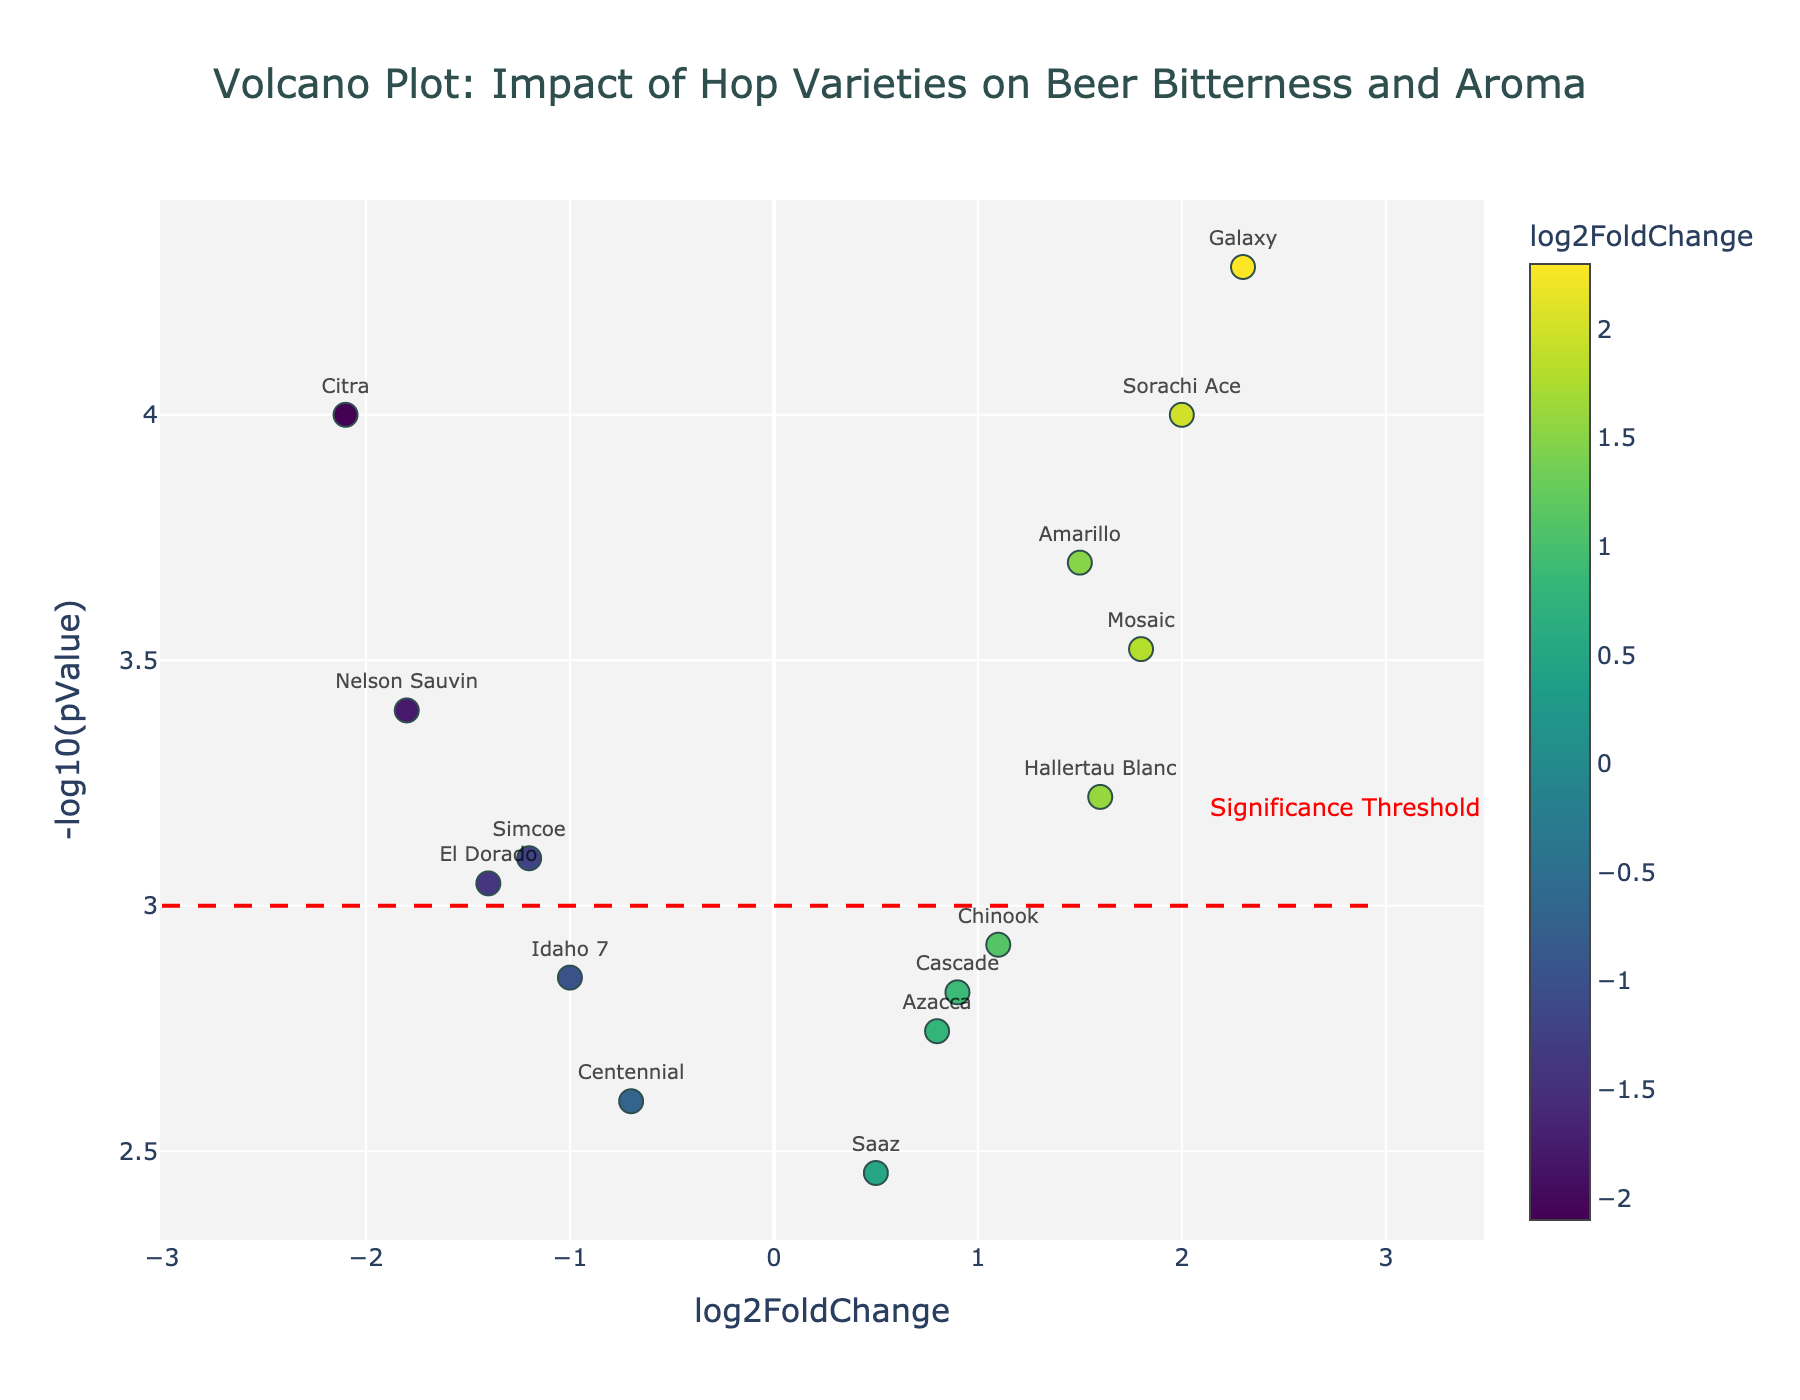Which hop variety has the highest absolute value of log2FoldChange? To find the variety with the highest absolute value of log2FoldChange, observe both positive and negative values. The hop variety with the most extreme value is "Galaxy" with a log2FoldChange of 2.3.
Answer: Galaxy What is the significance threshold for p-values in this plot? The plot shows a red dashed line at y = 3, which corresponds to the -log10(pValue) signifying the significance threshold for p-values.
Answer: -log10(pValue) = 3 How many hop varieties lie above the significance threshold? To determine this, count the data points above the red dashed line at y = 3. There are 8 data points above this threshold.
Answer: 8 Which hop variety has the smallest p-value? The smallest p-value corresponds to the highest -log10(pValue). "Galaxy" has the highest -log10(pValue), thus the smallest p-value.
Answer: Galaxy What is the log2FoldChange for Citra? The log2FoldChange for Citra can be read directly from the plot, where Citra is at a log2FoldChange of -2.1.
Answer: -2.1 Which hop variety has the highest positive log2FoldChange and is considered significant? From the values above the significance threshold (y > 3), find the highest positive log2FoldChange. "Galaxy" has the highest positive log2FoldChange of 2.3 and is above the threshold.
Answer: Galaxy Name two hop varieties with negative log2FoldChange and significant p-values. Look for points with negative log2FoldChange that are above the red dashed line. "Citra" and "Nelson Sauvin" fit this criterion.
Answer: Citra, Nelson Sauvin Which hop variety has a log2FoldChange closest to 0. Scan for the data point closest to the x-axis at log2FoldChange = 0. "Saaz" has a log2FoldChange near 0 with a value of 0.5.
Answer: Saaz What is the log2FoldChange difference between Galaxy and Simcoe? Calculate the difference: Galaxy (2.3) - Simcoe (-1.2) = 2.3 + 1.2 = 3.5
Answer: 3.5 Which hop variety has a log2FoldChange value of approximately 1.5? Locate the data point on the plot that has a log2FoldChange around 1.5. The hop variety is "Amarillo".
Answer: Amarillo 